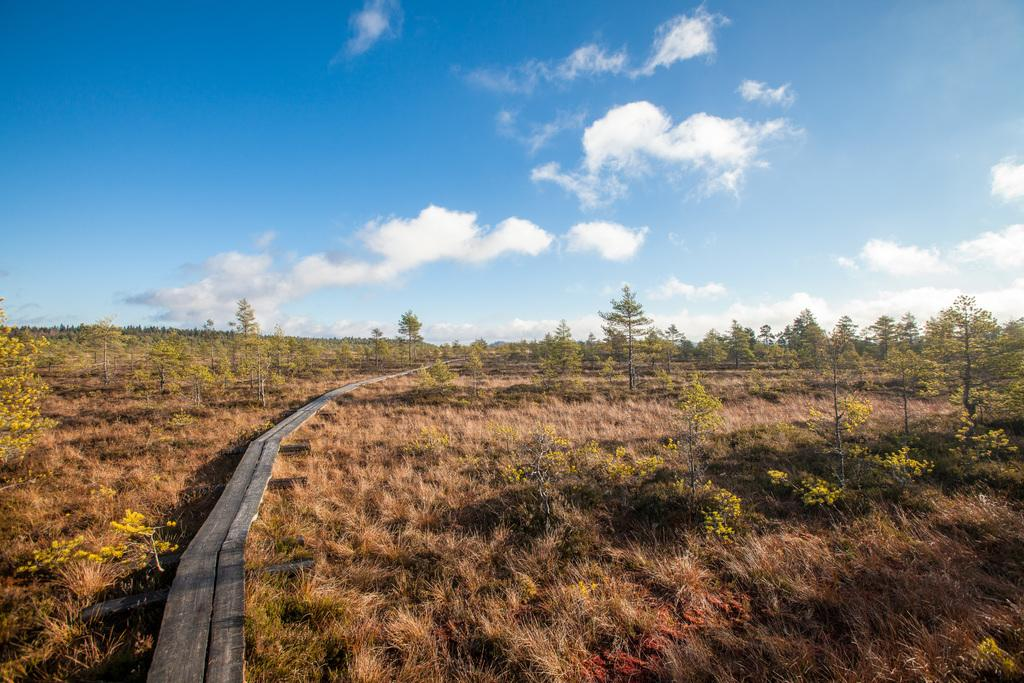What type of vegetation can be seen in the image? There is grass, trees, and plants in the image. What type of material is used for the wooden planks in the image? The wooden planks in the image are made of wood. What is visible in the background of the image? The sky is visible in the background of the image. What can be seen in the sky in the image? Clouds are present in the sky in the image. How many cattle can be seen grazing on the grass in the image? There are no cattle present in the image; it only features grass, trees, plants, wooden planks, and the sky with clouds. 